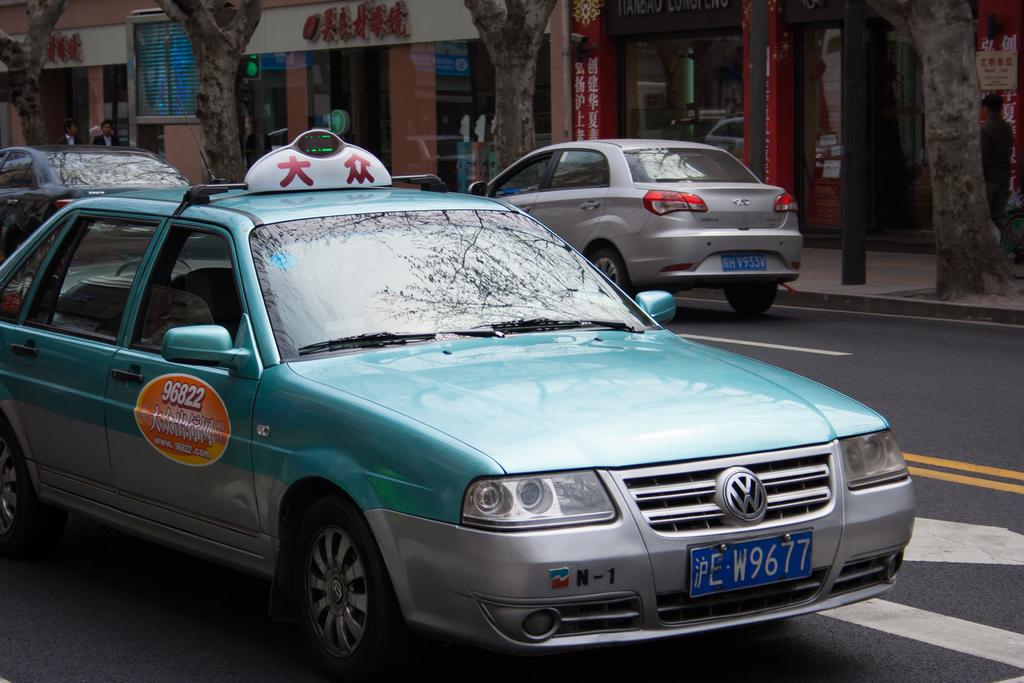What is the license plate of this taxi?
Ensure brevity in your answer.  W9677. What is the taxi's identification code on the passenger door?
Your answer should be very brief. 96822. 